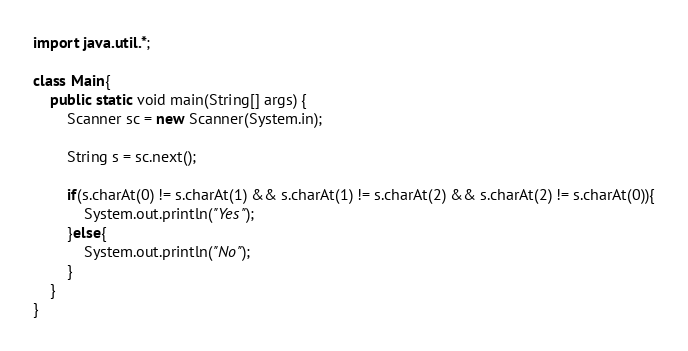Convert code to text. <code><loc_0><loc_0><loc_500><loc_500><_Java_>import java.util.*;

class Main{
    public static void main(String[] args) {
        Scanner sc = new Scanner(System.in);

        String s = sc.next();

        if(s.charAt(0) != s.charAt(1) && s.charAt(1) != s.charAt(2) && s.charAt(2) != s.charAt(0)){
            System.out.println("Yes");
        }else{
            System.out.println("No");
        }
    }
}</code> 